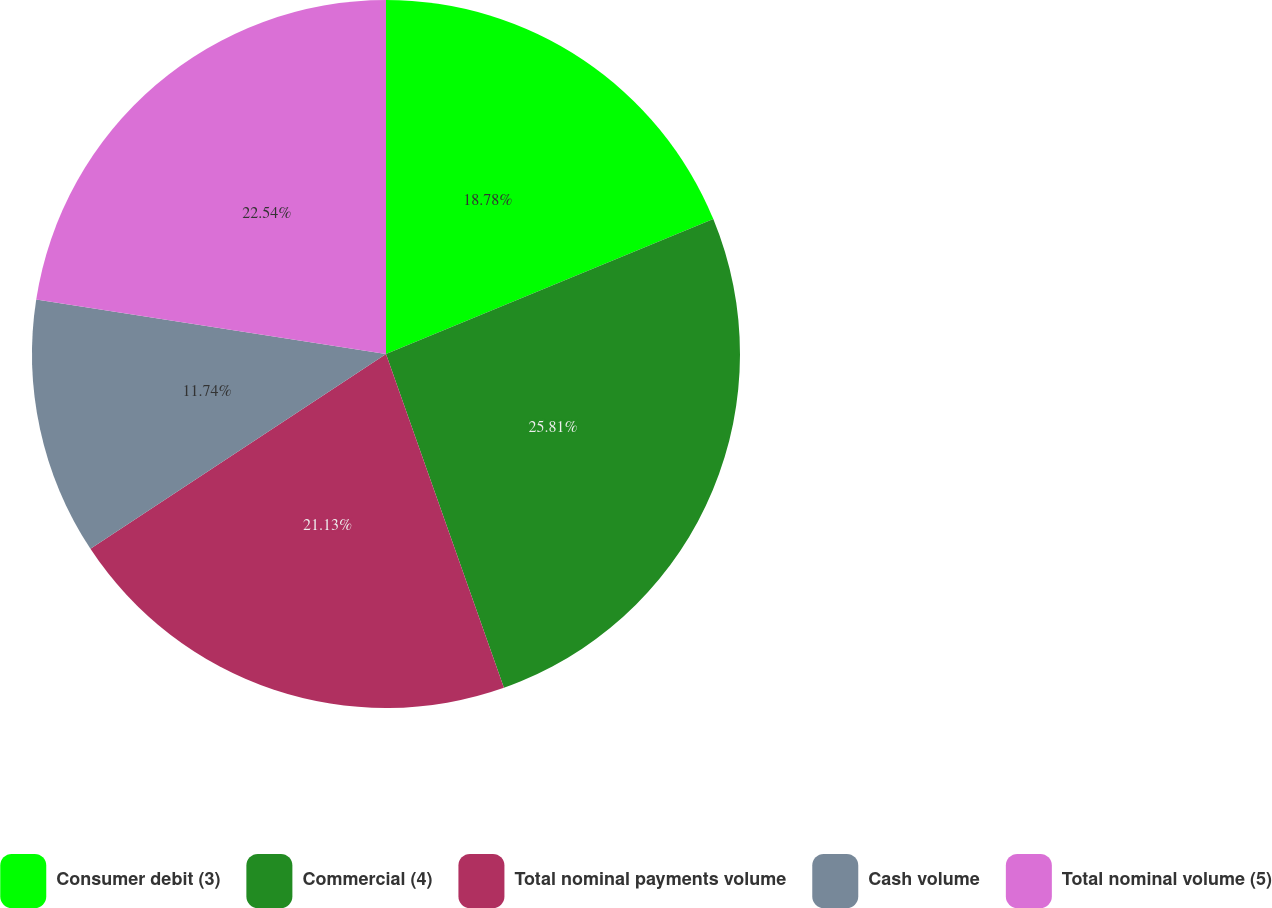<chart> <loc_0><loc_0><loc_500><loc_500><pie_chart><fcel>Consumer debit (3)<fcel>Commercial (4)<fcel>Total nominal payments volume<fcel>Cash volume<fcel>Total nominal volume (5)<nl><fcel>18.78%<fcel>25.82%<fcel>21.13%<fcel>11.74%<fcel>22.54%<nl></chart> 